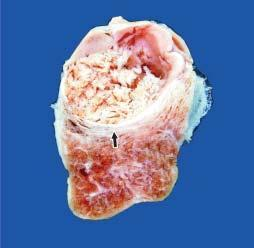what shows a single nodule separated from the rest of thyroid parenchyma by incomplete fibrous septa?
Answer the question using a single word or phrase. Cut surface 